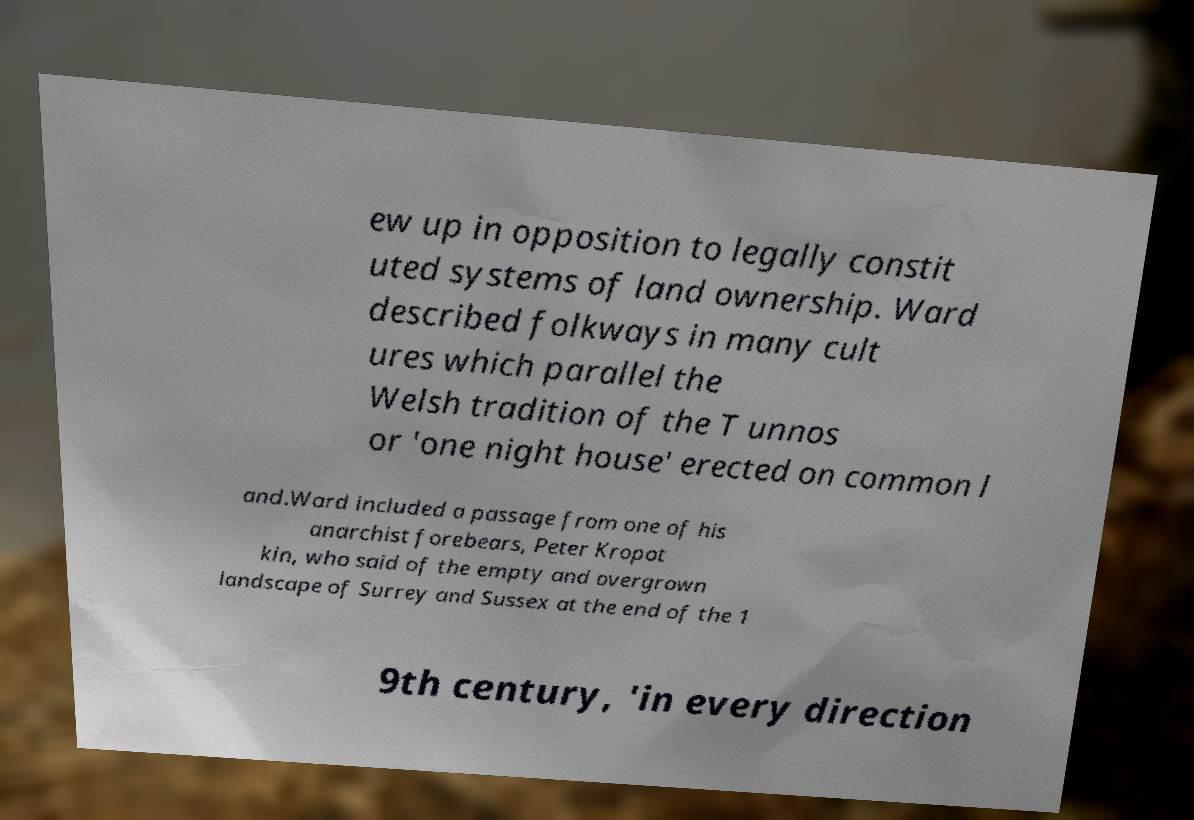What messages or text are displayed in this image? I need them in a readable, typed format. ew up in opposition to legally constit uted systems of land ownership. Ward described folkways in many cult ures which parallel the Welsh tradition of the T unnos or 'one night house' erected on common l and.Ward included a passage from one of his anarchist forebears, Peter Kropot kin, who said of the empty and overgrown landscape of Surrey and Sussex at the end of the 1 9th century, 'in every direction 